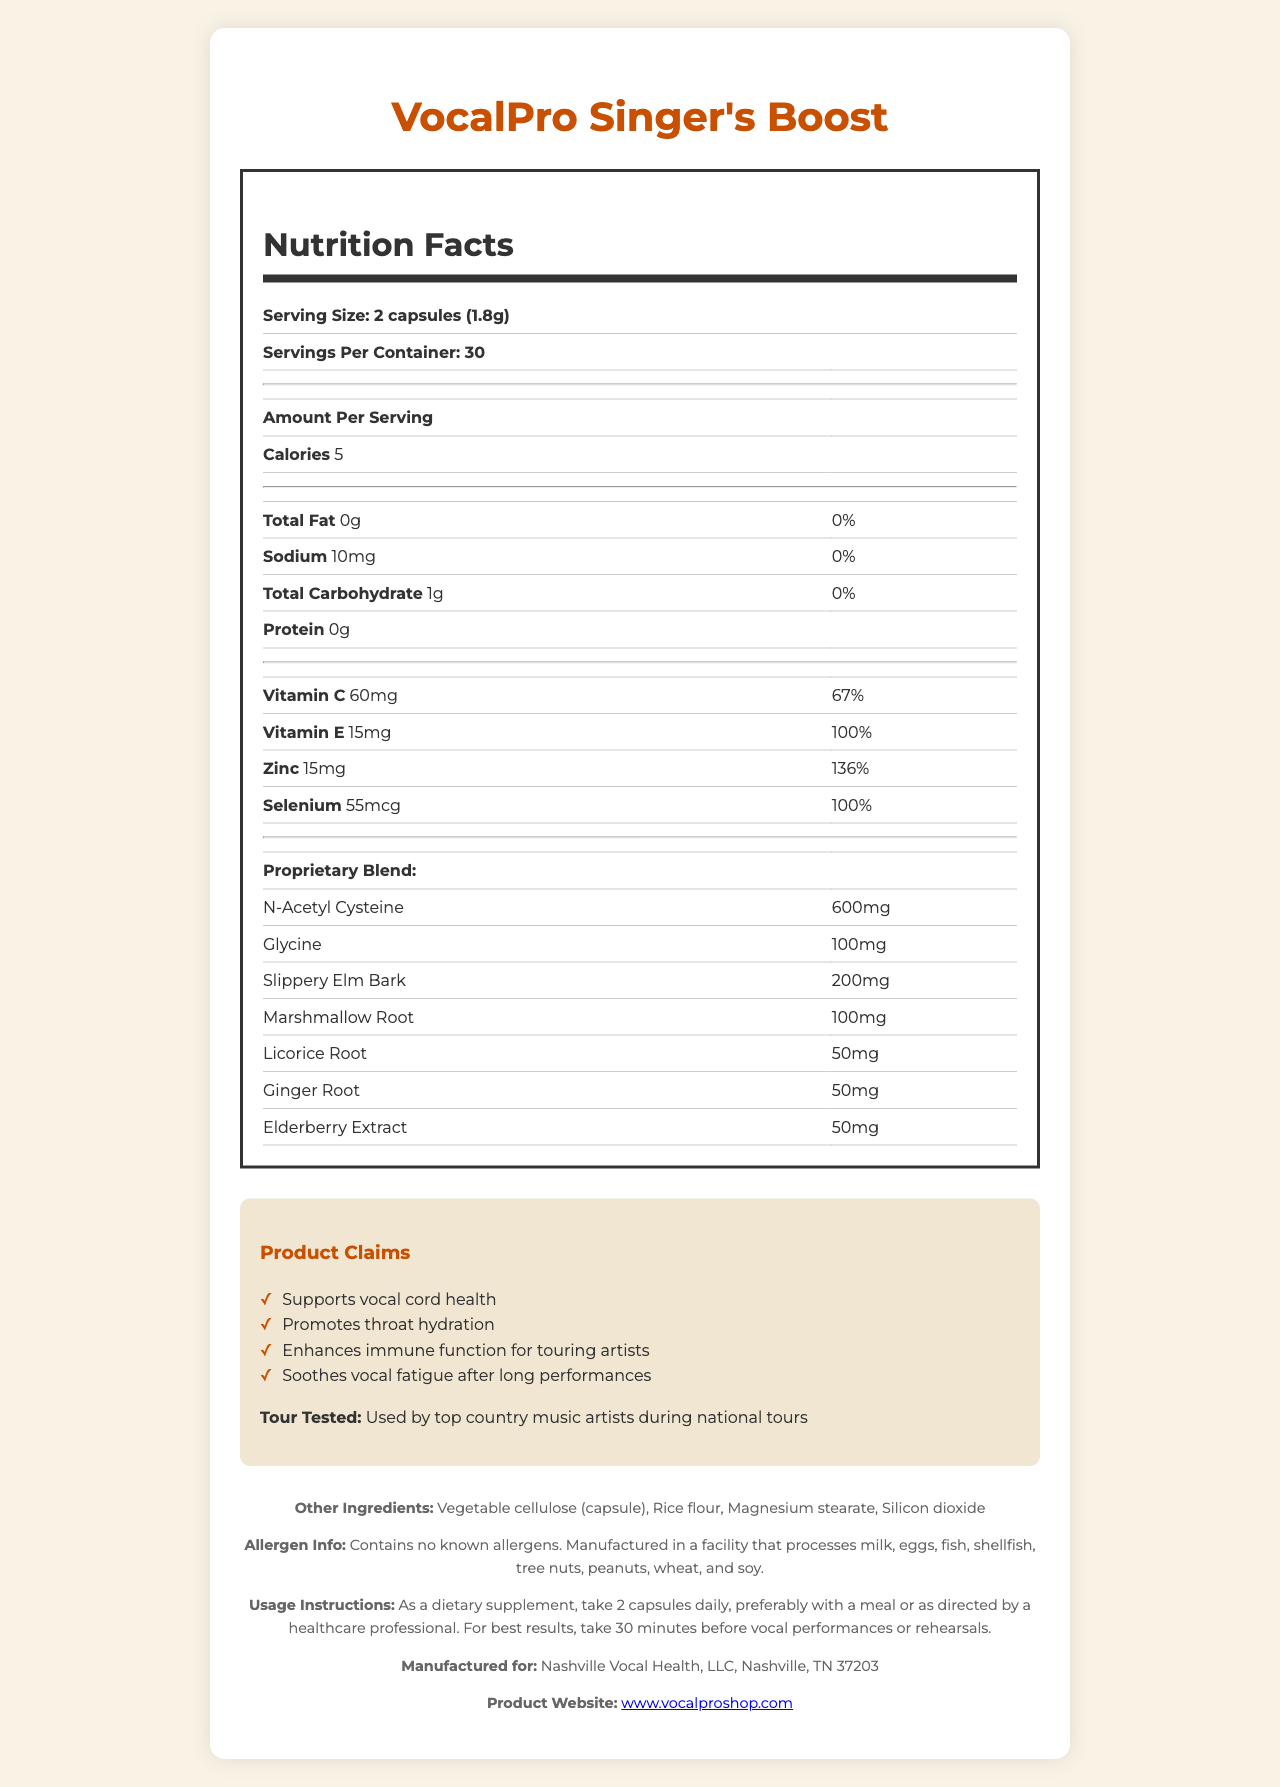what is the serving size of VocalPro Singer's Boost? The document lists the serving size as "2 capsules (1.8g)" under the Nutrition Facts.
Answer: 2 capsules (1.8g) how many servings are there per container? The document states that there are 30 servings per container.
Answer: 30 what fact is inferred about the product's fat content? Under the Nutrition Facts, it mentions that the total fat is 0g.
Answer: 0g what is the amount of vitamin C per serving? The Nutrition Facts section lists 60mg of vitamin C per serving.
Answer: 60mg what is one of the key ingredients mentioned for promoting vocal health? Slippery Elm Bark is listed as one of the ingredients and is known for promoting vocal health.
Answer: Slippery Elm Bark which vitamin has the highest % Daily Value per serving? A. Vitamin C B. Vitamin E C. Zinc D. Selenium Zinc has a % Daily Value of 136%, higher than Vitamin C (67%), Vitamin E (100%), and Selenium (100%).
Answer: C what is the function of the proprietary blend ingredients? A. Supports vocal cord health B. Enhances immune function C. Promotes throat hydration D. All of the above The product claims to "Support vocal cord health," "Enhance immune function," and "Promote throat hydration," which are likely functions of the proprietary blend ingredients.
Answer: D is the VocalPro Singer's Boost tested by artists? The document states "Tour Tested: Used by top country music artists during national tours."
Answer: Yes how would you summarize the intent and benefits of the VocalPro Singer's Boost supplement? The document describes the various benefits of the supplement, including support for vocal cord health, hydration, immune function, and relief from vocal fatigue. It also highlights that the product is trusted by top artists.
Answer: The VocalPro Singer's Boost supplement is designed to support the vocal health of singers. It contains various ingredients like N-Acetyl Cysteine, Slippery Elm Bark, and vitamins, which together help to promote throat hydration, enhance immune function, and soothe vocal fatigue. It is also tested by top country music artists. what other ingredients are included in the capsules? The document lists these ingredients under the "Other Ingredients" section.
Answer: Vegetable cellulose (capsule), Rice flour, Magnesium stearate, Silicon dioxide what is the calorie content per serving? The Nutrition Facts state that each serving contains 5 calories.
Answer: 5 calories how is the VocalPro Singer's Boost recommended to be taken? The document provides this instruction under the "Usage Instructions" section.
Answer: Take 2 capsules daily, preferably with a meal or as directed by a healthcare professional. where is the VocalPro Singer's Boost manufactured? The document specifies it is manufactured for Nashville Vocal Health, LLC, Nashville, TN 37203.
Answer: Nashville, TN 37203 can this product be taken by someone with nut allergies? The allergen info section states that it contains no known allergens but is manufactured in a facility that processes nuts, implying a risk of cross-contamination.
Answer: Not enough information does the VocalPro Singer's Boost label list any protein content per serving? The Nutrition Facts section lists "Protein: 0g."
Answer: No 